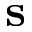Convert formula to latex. <formula><loc_0><loc_0><loc_500><loc_500>s</formula> 